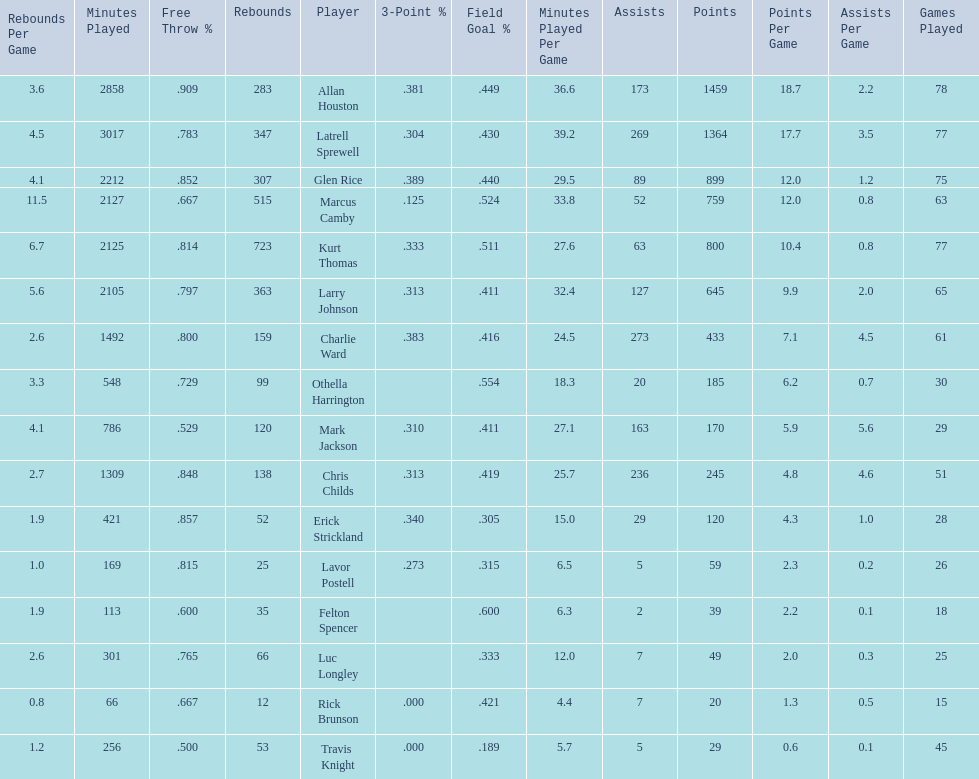Who scored more points, larry johnson or charlie ward? Larry Johnson. 